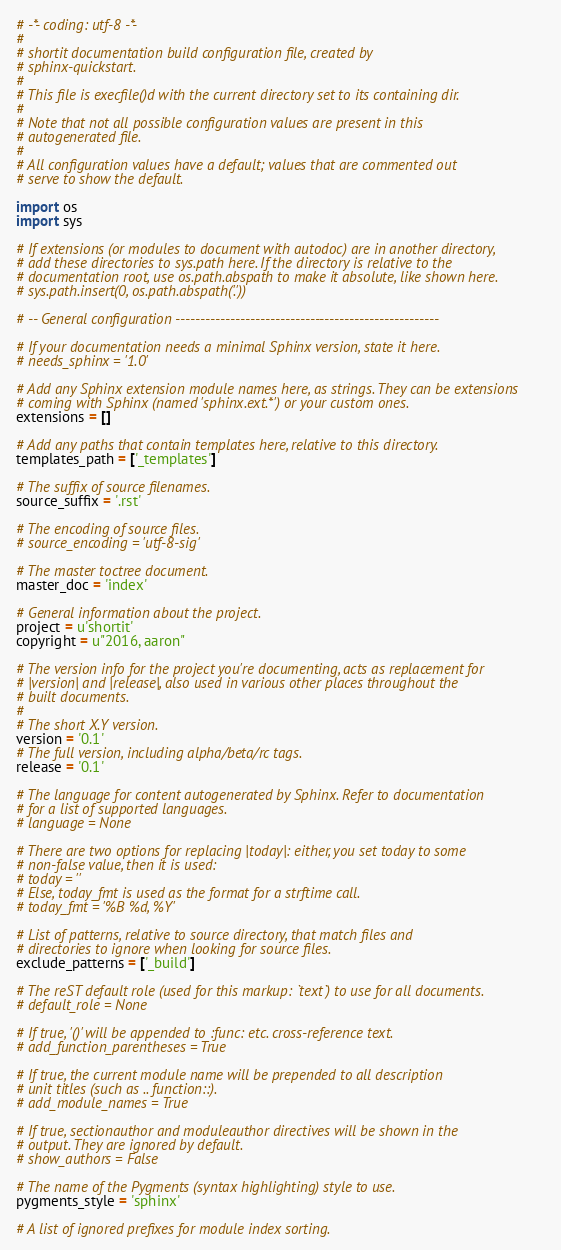<code> <loc_0><loc_0><loc_500><loc_500><_Python_># -*- coding: utf-8 -*-
#
# shortit documentation build configuration file, created by
# sphinx-quickstart.
#
# This file is execfile()d with the current directory set to its containing dir.
#
# Note that not all possible configuration values are present in this
# autogenerated file.
#
# All configuration values have a default; values that are commented out
# serve to show the default.

import os
import sys

# If extensions (or modules to document with autodoc) are in another directory,
# add these directories to sys.path here. If the directory is relative to the
# documentation root, use os.path.abspath to make it absolute, like shown here.
# sys.path.insert(0, os.path.abspath('.'))

# -- General configuration -----------------------------------------------------

# If your documentation needs a minimal Sphinx version, state it here.
# needs_sphinx = '1.0'

# Add any Sphinx extension module names here, as strings. They can be extensions
# coming with Sphinx (named 'sphinx.ext.*') or your custom ones.
extensions = []

# Add any paths that contain templates here, relative to this directory.
templates_path = ['_templates']

# The suffix of source filenames.
source_suffix = '.rst'

# The encoding of source files.
# source_encoding = 'utf-8-sig'

# The master toctree document.
master_doc = 'index'

# General information about the project.
project = u'shortit'
copyright = u"2016, aaron"

# The version info for the project you're documenting, acts as replacement for
# |version| and |release|, also used in various other places throughout the
# built documents.
#
# The short X.Y version.
version = '0.1'
# The full version, including alpha/beta/rc tags.
release = '0.1'

# The language for content autogenerated by Sphinx. Refer to documentation
# for a list of supported languages.
# language = None

# There are two options for replacing |today|: either, you set today to some
# non-false value, then it is used:
# today = ''
# Else, today_fmt is used as the format for a strftime call.
# today_fmt = '%B %d, %Y'

# List of patterns, relative to source directory, that match files and
# directories to ignore when looking for source files.
exclude_patterns = ['_build']

# The reST default role (used for this markup: `text`) to use for all documents.
# default_role = None

# If true, '()' will be appended to :func: etc. cross-reference text.
# add_function_parentheses = True

# If true, the current module name will be prepended to all description
# unit titles (such as .. function::).
# add_module_names = True

# If true, sectionauthor and moduleauthor directives will be shown in the
# output. They are ignored by default.
# show_authors = False

# The name of the Pygments (syntax highlighting) style to use.
pygments_style = 'sphinx'

# A list of ignored prefixes for module index sorting.</code> 